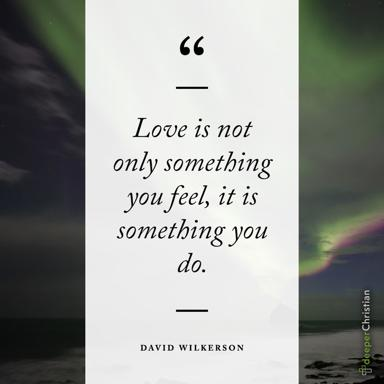Can you explain the quote by David Wilkerson? David Wilkerson's quote, "Love is not only something you feel, it is something you do," emphasizes that love transcends mere emotional experience. It compels us to act in ways that affirm our love through support, kindness, and dedication. This perspective encourages us to consider love as a series of deliberate acts that reinforce the emotional bonds we feel, highlighting the dual nature of love as both a feeling and a commitment. 